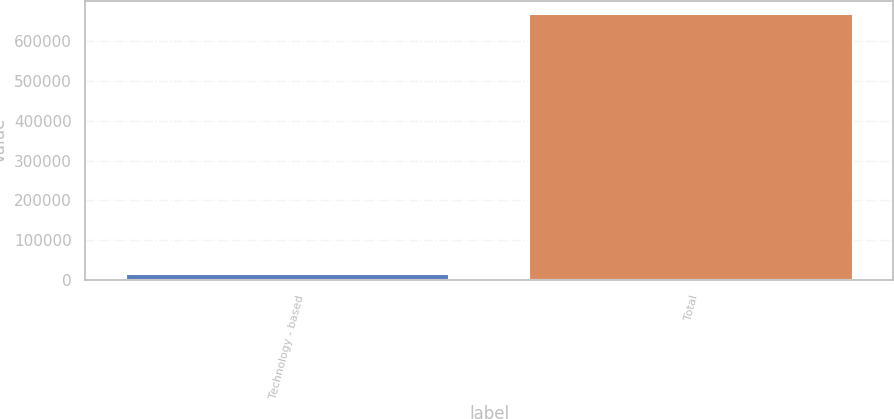<chart> <loc_0><loc_0><loc_500><loc_500><bar_chart><fcel>Technology - based<fcel>Total<nl><fcel>16200<fcel>666600<nl></chart> 